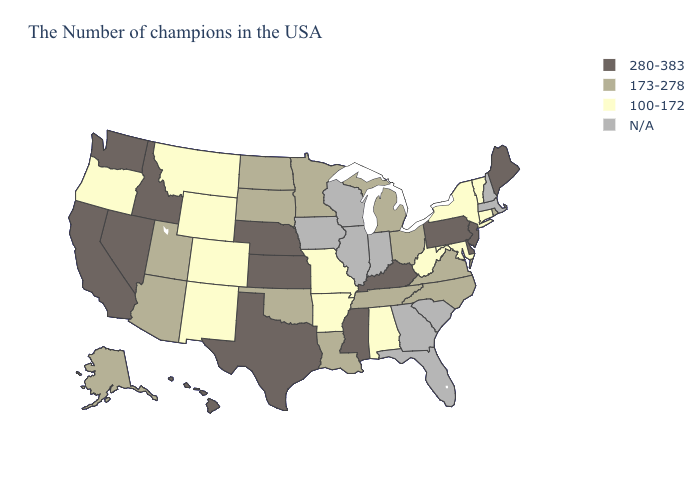Does Ohio have the lowest value in the MidWest?
Quick response, please. No. What is the highest value in states that border Rhode Island?
Keep it brief. 100-172. Name the states that have a value in the range 173-278?
Quick response, please. Rhode Island, Virginia, North Carolina, Ohio, Michigan, Tennessee, Louisiana, Minnesota, Oklahoma, South Dakota, North Dakota, Utah, Arizona, Alaska. What is the value of Maryland?
Short answer required. 100-172. Is the legend a continuous bar?
Keep it brief. No. Which states hav the highest value in the MidWest?
Write a very short answer. Kansas, Nebraska. Name the states that have a value in the range 173-278?
Answer briefly. Rhode Island, Virginia, North Carolina, Ohio, Michigan, Tennessee, Louisiana, Minnesota, Oklahoma, South Dakota, North Dakota, Utah, Arizona, Alaska. Which states have the highest value in the USA?
Keep it brief. Maine, New Jersey, Delaware, Pennsylvania, Kentucky, Mississippi, Kansas, Nebraska, Texas, Idaho, Nevada, California, Washington, Hawaii. What is the value of Maine?
Keep it brief. 280-383. What is the value of Vermont?
Give a very brief answer. 100-172. What is the value of Alaska?
Quick response, please. 173-278. Among the states that border Virginia , which have the highest value?
Answer briefly. Kentucky. 